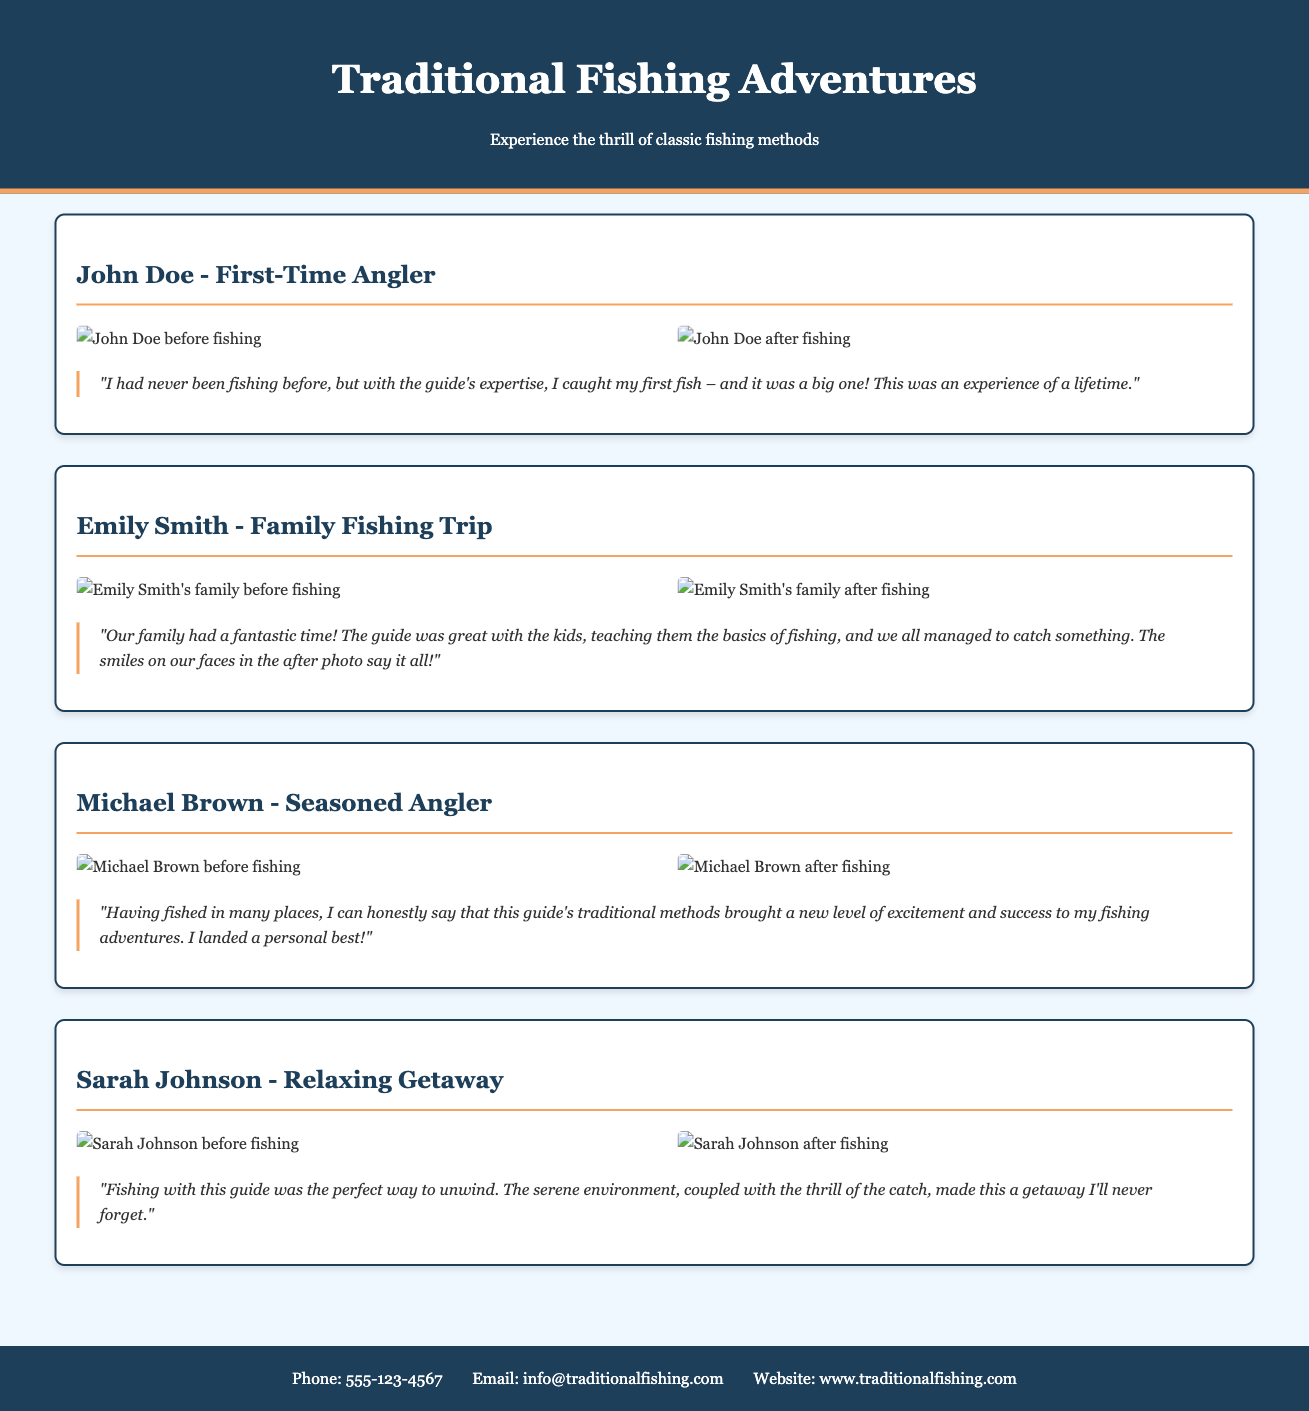What is the name of the first client featured? The document begins with a testimonial by John Doe.
Answer: John Doe How many total testimonials are presented? There are four testimonials shared in the document.
Answer: Four What is the phone number provided in the contact information? The document lists the phone number for contact as 555-123-4567.
Answer: 555-123-4567 What was Michael Brown's claim regarding his fishing experience? Michael Brown stated that traditional methods brought a new level of excitement and success to his adventures.
Answer: A new level of excitement and success Which client emphasized the family aspect of their fishing trip? Emily Smith discussed her family's fantastic time during the fishing trip.
Answer: Emily Smith What did Sarah Johnson use to describe her fishing getaway? Sarah Johnson described her fishing experience as the perfect way to unwind.
Answer: The perfect way to unwind What photo type is included alongside each testimonial? Each testimonial features before-and-after photos of the clients' fishing experiences.
Answer: Before-and-after photos What color is the header background of the document? The header background is colored in a dark shade, specifically #1e3f5a.
Answer: #1e3f5a 